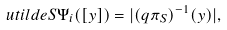<formula> <loc_0><loc_0><loc_500><loc_500>\ u t i l d e { S \Psi _ { i } } ( [ y ] ) = | ( q \pi _ { S } ) ^ { - 1 } ( y ) | ,</formula> 